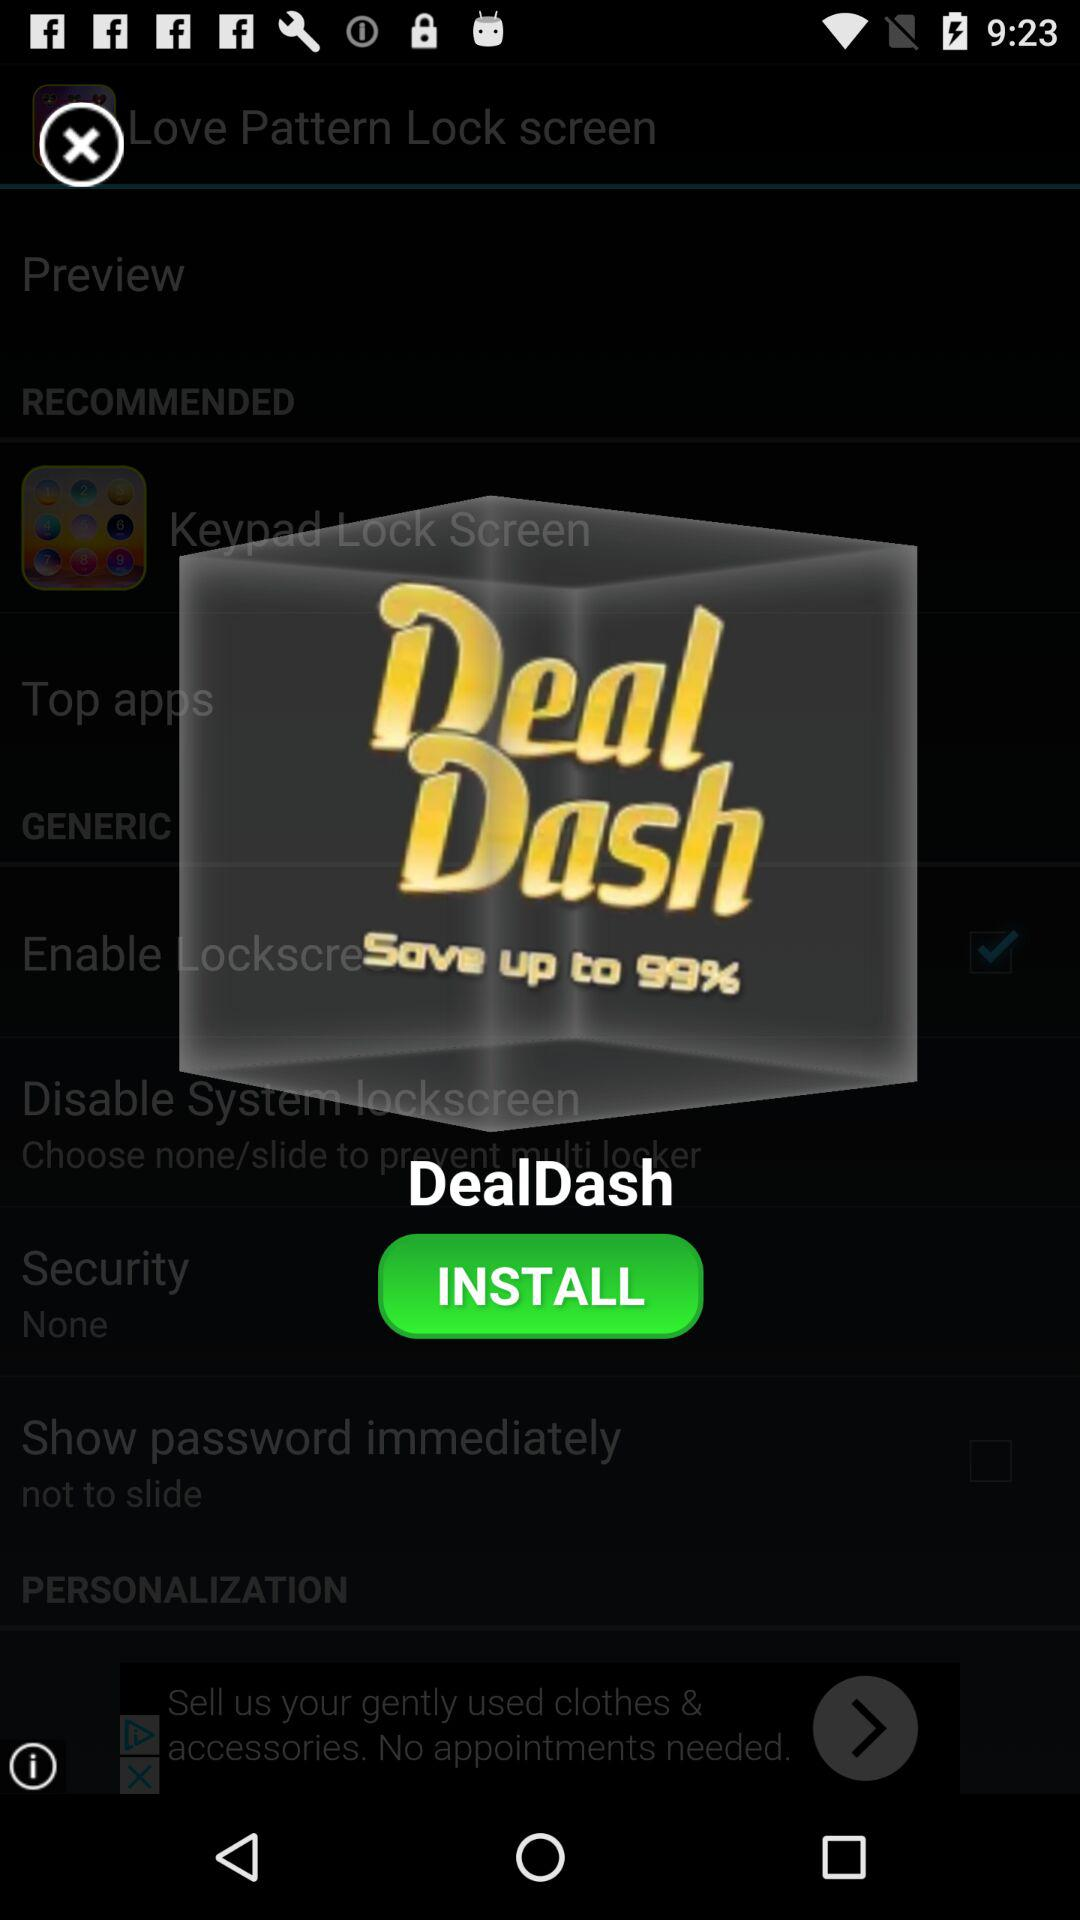How much can we save on dealdash? We can save up to 99%. 